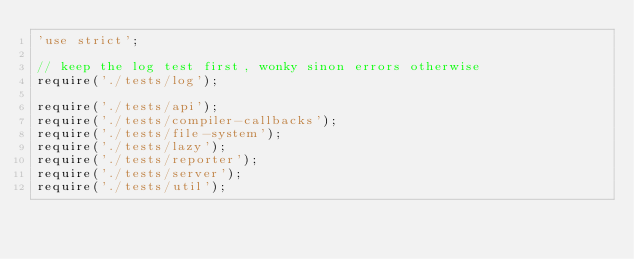<code> <loc_0><loc_0><loc_500><loc_500><_JavaScript_>'use strict';

// keep the log test first, wonky sinon errors otherwise
require('./tests/log');

require('./tests/api');
require('./tests/compiler-callbacks');
require('./tests/file-system');
require('./tests/lazy');
require('./tests/reporter');
require('./tests/server');
require('./tests/util');
</code> 